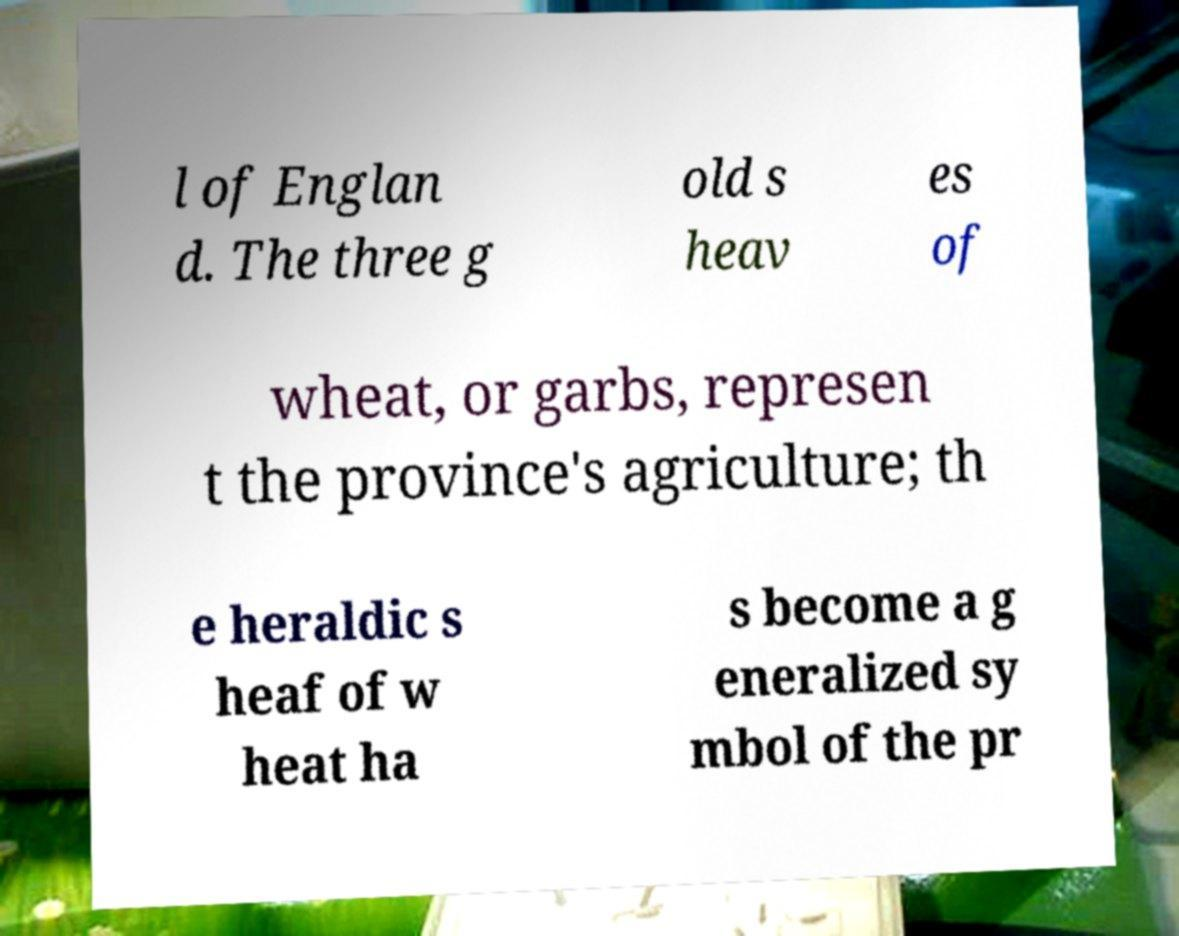Can you accurately transcribe the text from the provided image for me? l of Englan d. The three g old s heav es of wheat, or garbs, represen t the province's agriculture; th e heraldic s heaf of w heat ha s become a g eneralized sy mbol of the pr 